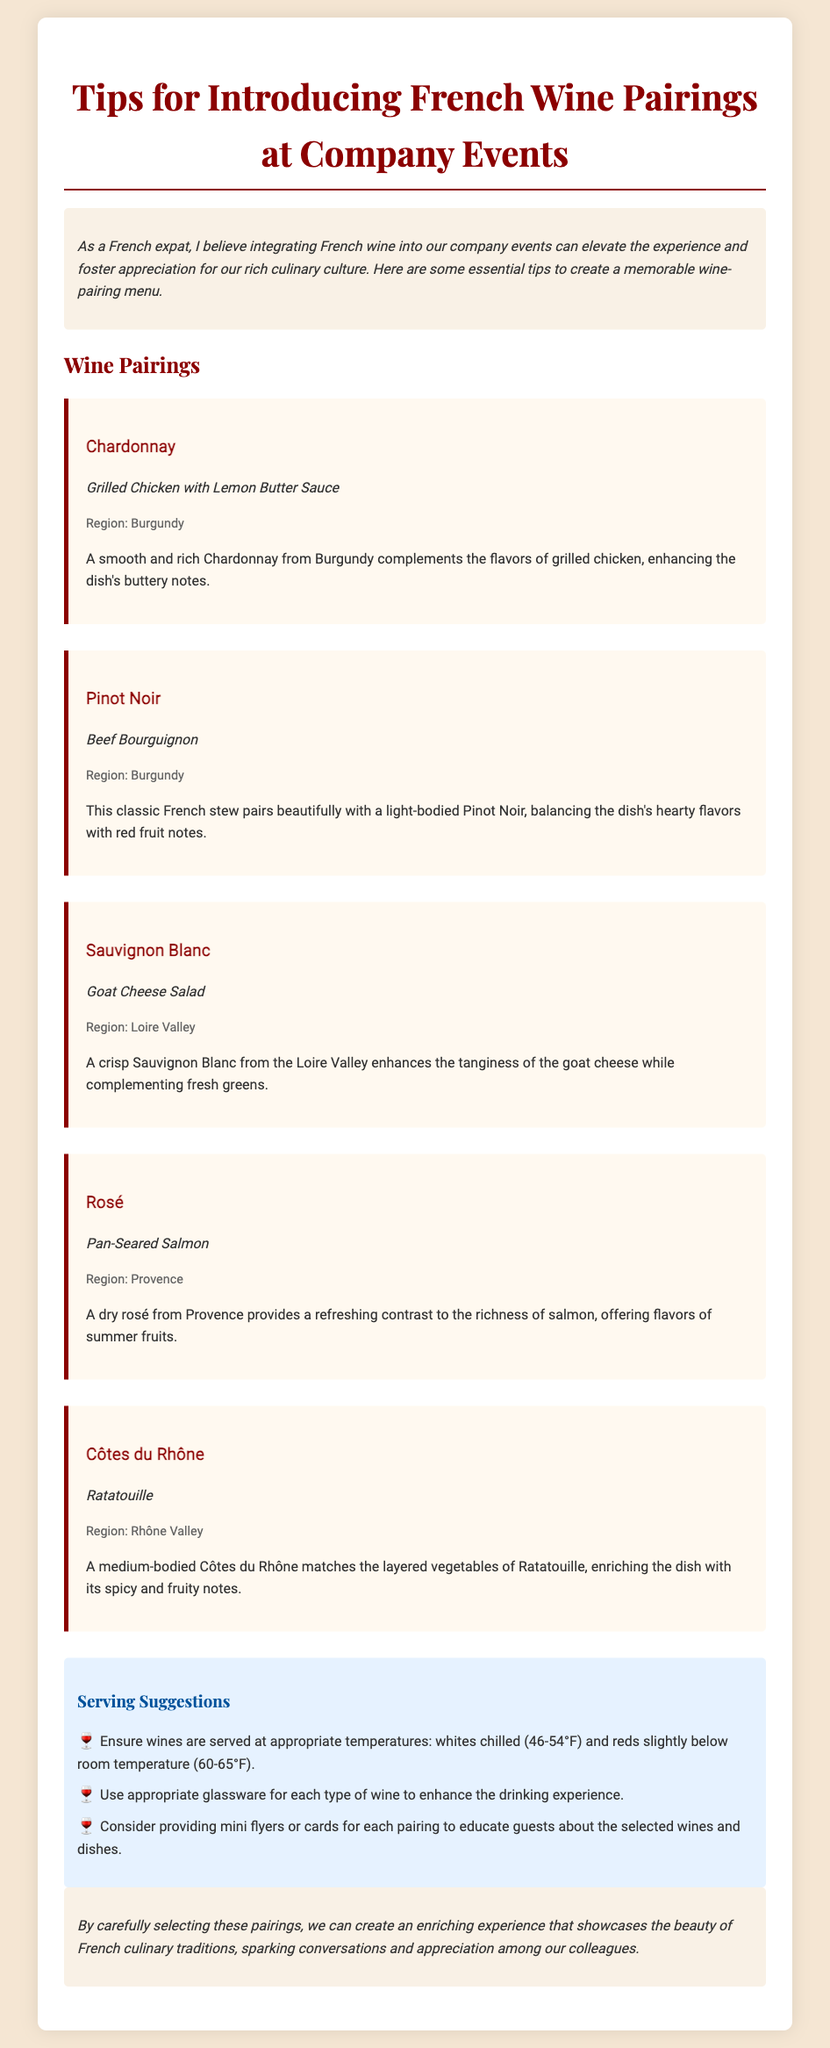What is the first wine pairing listed? The first wine pairing listed in the document is Chardonnay paired with Grilled Chicken with Lemon Butter Sauce.
Answer: Chardonnay What region is associated with Pinot Noir? Pinot Noir is associated with the Burgundy region.
Answer: Burgundy What type of wine pairs with Goat Cheese Salad? The type of wine that pairs with Goat Cheese Salad is Sauvignon Blanc.
Answer: Sauvignon Blanc What is one serving suggestion mentioned? One serving suggestion mentioned is to ensure wines are served at appropriate temperatures.
Answer: Appropriate temperatures How does Rosé complement Pan-Seared Salmon? Rosé provides a refreshing contrast to the richness of salmon, offering flavors of summer fruits.
Answer: Refreshing contrast What is the purpose of providing mini flyers or cards? The purpose of providing mini flyers or cards is to educate guests about the selected wines and dishes.
Answer: Educate guests How many wine pairings are mentioned in the document? There are a total of five wine pairings mentioned in the document.
Answer: Five What is the overall theme of the document? The overall theme of the document is tips for introducing French wine pairings at company events.
Answer: French wine pairings What style of salad is paired with Sauvignon Blanc? The style of salad paired with Sauvignon Blanc is Goat Cheese Salad.
Answer: Goat Cheese Salad 